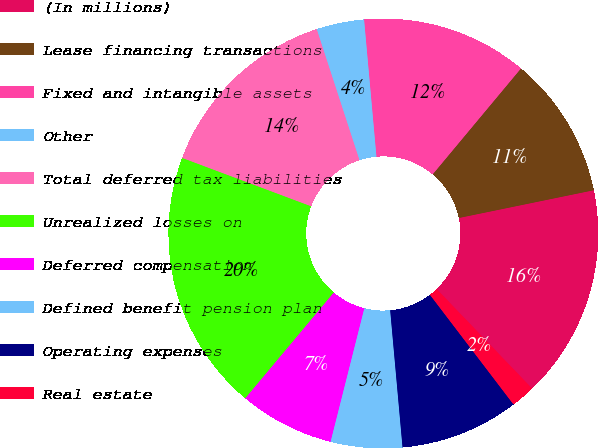<chart> <loc_0><loc_0><loc_500><loc_500><pie_chart><fcel>(In millions)<fcel>Lease financing transactions<fcel>Fixed and intangible assets<fcel>Other<fcel>Total deferred tax liabilities<fcel>Unrealized losses on<fcel>Deferred compensation<fcel>Defined benefit pension plan<fcel>Operating expenses<fcel>Real estate<nl><fcel>16.06%<fcel>10.71%<fcel>12.49%<fcel>3.59%<fcel>14.27%<fcel>19.62%<fcel>7.15%<fcel>5.37%<fcel>8.93%<fcel>1.81%<nl></chart> 